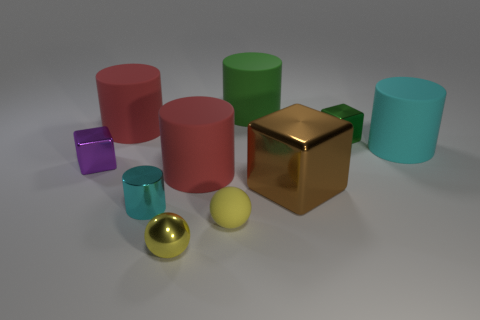Subtract all green cylinders. How many cylinders are left? 4 Subtract 2 cylinders. How many cylinders are left? 3 Subtract all small metallic cylinders. How many cylinders are left? 4 Subtract all purple cylinders. Subtract all brown balls. How many cylinders are left? 5 Subtract all cubes. How many objects are left? 7 Add 5 tiny metal blocks. How many tiny metal blocks exist? 7 Subtract 1 brown cubes. How many objects are left? 9 Subtract all big gray objects. Subtract all large brown objects. How many objects are left? 9 Add 6 tiny purple things. How many tiny purple things are left? 7 